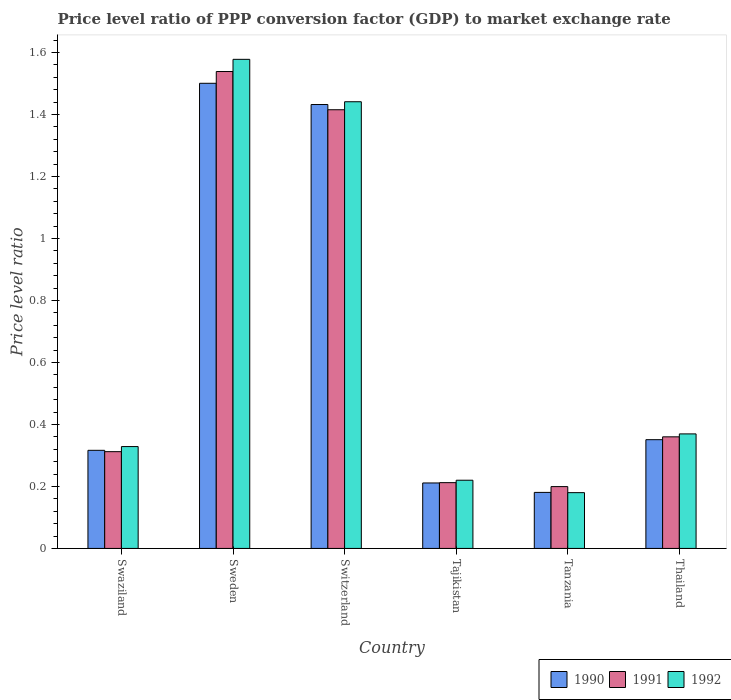How many different coloured bars are there?
Offer a very short reply. 3. Are the number of bars on each tick of the X-axis equal?
Make the answer very short. Yes. What is the label of the 6th group of bars from the left?
Keep it short and to the point. Thailand. What is the price level ratio in 1992 in Thailand?
Offer a terse response. 0.37. Across all countries, what is the maximum price level ratio in 1991?
Your answer should be very brief. 1.54. Across all countries, what is the minimum price level ratio in 1992?
Offer a very short reply. 0.18. In which country was the price level ratio in 1990 minimum?
Provide a succinct answer. Tanzania. What is the total price level ratio in 1992 in the graph?
Give a very brief answer. 4.12. What is the difference between the price level ratio in 1990 in Swaziland and that in Thailand?
Offer a terse response. -0.03. What is the difference between the price level ratio in 1992 in Thailand and the price level ratio in 1990 in Tanzania?
Provide a succinct answer. 0.19. What is the average price level ratio in 1990 per country?
Ensure brevity in your answer.  0.67. What is the difference between the price level ratio of/in 1991 and price level ratio of/in 1990 in Tajikistan?
Your response must be concise. 0. In how many countries, is the price level ratio in 1991 greater than 0.7200000000000001?
Your answer should be compact. 2. What is the ratio of the price level ratio in 1990 in Tajikistan to that in Thailand?
Your answer should be compact. 0.6. Is the difference between the price level ratio in 1991 in Swaziland and Sweden greater than the difference between the price level ratio in 1990 in Swaziland and Sweden?
Ensure brevity in your answer.  No. What is the difference between the highest and the second highest price level ratio in 1991?
Give a very brief answer. -1.18. What is the difference between the highest and the lowest price level ratio in 1990?
Make the answer very short. 1.32. In how many countries, is the price level ratio in 1992 greater than the average price level ratio in 1992 taken over all countries?
Keep it short and to the point. 2. What does the 2nd bar from the left in Tajikistan represents?
Ensure brevity in your answer.  1991. Is it the case that in every country, the sum of the price level ratio in 1992 and price level ratio in 1990 is greater than the price level ratio in 1991?
Give a very brief answer. Yes. How many bars are there?
Your answer should be compact. 18. How many countries are there in the graph?
Provide a short and direct response. 6. Does the graph contain any zero values?
Your answer should be compact. No. Where does the legend appear in the graph?
Your answer should be compact. Bottom right. How are the legend labels stacked?
Your answer should be very brief. Horizontal. What is the title of the graph?
Ensure brevity in your answer.  Price level ratio of PPP conversion factor (GDP) to market exchange rate. What is the label or title of the X-axis?
Give a very brief answer. Country. What is the label or title of the Y-axis?
Provide a short and direct response. Price level ratio. What is the Price level ratio in 1990 in Swaziland?
Offer a terse response. 0.32. What is the Price level ratio of 1991 in Swaziland?
Offer a terse response. 0.31. What is the Price level ratio in 1992 in Swaziland?
Provide a short and direct response. 0.33. What is the Price level ratio in 1990 in Sweden?
Offer a terse response. 1.5. What is the Price level ratio in 1991 in Sweden?
Keep it short and to the point. 1.54. What is the Price level ratio in 1992 in Sweden?
Provide a short and direct response. 1.58. What is the Price level ratio of 1990 in Switzerland?
Offer a terse response. 1.43. What is the Price level ratio of 1991 in Switzerland?
Offer a terse response. 1.42. What is the Price level ratio of 1992 in Switzerland?
Ensure brevity in your answer.  1.44. What is the Price level ratio in 1990 in Tajikistan?
Your response must be concise. 0.21. What is the Price level ratio in 1991 in Tajikistan?
Keep it short and to the point. 0.21. What is the Price level ratio of 1992 in Tajikistan?
Ensure brevity in your answer.  0.22. What is the Price level ratio in 1990 in Tanzania?
Offer a terse response. 0.18. What is the Price level ratio in 1991 in Tanzania?
Keep it short and to the point. 0.2. What is the Price level ratio in 1992 in Tanzania?
Ensure brevity in your answer.  0.18. What is the Price level ratio of 1990 in Thailand?
Your response must be concise. 0.35. What is the Price level ratio in 1991 in Thailand?
Ensure brevity in your answer.  0.36. What is the Price level ratio in 1992 in Thailand?
Keep it short and to the point. 0.37. Across all countries, what is the maximum Price level ratio in 1990?
Give a very brief answer. 1.5. Across all countries, what is the maximum Price level ratio in 1991?
Provide a succinct answer. 1.54. Across all countries, what is the maximum Price level ratio of 1992?
Provide a short and direct response. 1.58. Across all countries, what is the minimum Price level ratio in 1990?
Ensure brevity in your answer.  0.18. Across all countries, what is the minimum Price level ratio of 1991?
Offer a terse response. 0.2. Across all countries, what is the minimum Price level ratio in 1992?
Provide a short and direct response. 0.18. What is the total Price level ratio of 1990 in the graph?
Make the answer very short. 3.99. What is the total Price level ratio in 1991 in the graph?
Your answer should be compact. 4.04. What is the total Price level ratio of 1992 in the graph?
Keep it short and to the point. 4.12. What is the difference between the Price level ratio of 1990 in Swaziland and that in Sweden?
Keep it short and to the point. -1.18. What is the difference between the Price level ratio of 1991 in Swaziland and that in Sweden?
Give a very brief answer. -1.23. What is the difference between the Price level ratio in 1992 in Swaziland and that in Sweden?
Give a very brief answer. -1.25. What is the difference between the Price level ratio of 1990 in Swaziland and that in Switzerland?
Provide a short and direct response. -1.12. What is the difference between the Price level ratio in 1991 in Swaziland and that in Switzerland?
Keep it short and to the point. -1.1. What is the difference between the Price level ratio of 1992 in Swaziland and that in Switzerland?
Provide a short and direct response. -1.11. What is the difference between the Price level ratio of 1990 in Swaziland and that in Tajikistan?
Make the answer very short. 0.11. What is the difference between the Price level ratio in 1991 in Swaziland and that in Tajikistan?
Your answer should be compact. 0.1. What is the difference between the Price level ratio of 1992 in Swaziland and that in Tajikistan?
Ensure brevity in your answer.  0.11. What is the difference between the Price level ratio in 1990 in Swaziland and that in Tanzania?
Offer a very short reply. 0.14. What is the difference between the Price level ratio of 1991 in Swaziland and that in Tanzania?
Provide a short and direct response. 0.11. What is the difference between the Price level ratio of 1992 in Swaziland and that in Tanzania?
Make the answer very short. 0.15. What is the difference between the Price level ratio of 1990 in Swaziland and that in Thailand?
Offer a very short reply. -0.03. What is the difference between the Price level ratio in 1991 in Swaziland and that in Thailand?
Your answer should be very brief. -0.05. What is the difference between the Price level ratio in 1992 in Swaziland and that in Thailand?
Offer a very short reply. -0.04. What is the difference between the Price level ratio in 1990 in Sweden and that in Switzerland?
Your answer should be compact. 0.07. What is the difference between the Price level ratio of 1991 in Sweden and that in Switzerland?
Give a very brief answer. 0.12. What is the difference between the Price level ratio of 1992 in Sweden and that in Switzerland?
Offer a terse response. 0.14. What is the difference between the Price level ratio in 1990 in Sweden and that in Tajikistan?
Your response must be concise. 1.29. What is the difference between the Price level ratio of 1991 in Sweden and that in Tajikistan?
Provide a succinct answer. 1.33. What is the difference between the Price level ratio in 1992 in Sweden and that in Tajikistan?
Your answer should be compact. 1.36. What is the difference between the Price level ratio in 1990 in Sweden and that in Tanzania?
Make the answer very short. 1.32. What is the difference between the Price level ratio of 1991 in Sweden and that in Tanzania?
Make the answer very short. 1.34. What is the difference between the Price level ratio in 1992 in Sweden and that in Tanzania?
Offer a terse response. 1.4. What is the difference between the Price level ratio in 1990 in Sweden and that in Thailand?
Your response must be concise. 1.15. What is the difference between the Price level ratio in 1991 in Sweden and that in Thailand?
Offer a very short reply. 1.18. What is the difference between the Price level ratio in 1992 in Sweden and that in Thailand?
Your response must be concise. 1.21. What is the difference between the Price level ratio in 1990 in Switzerland and that in Tajikistan?
Offer a very short reply. 1.22. What is the difference between the Price level ratio of 1991 in Switzerland and that in Tajikistan?
Offer a very short reply. 1.2. What is the difference between the Price level ratio in 1992 in Switzerland and that in Tajikistan?
Give a very brief answer. 1.22. What is the difference between the Price level ratio of 1990 in Switzerland and that in Tanzania?
Make the answer very short. 1.25. What is the difference between the Price level ratio in 1991 in Switzerland and that in Tanzania?
Your answer should be very brief. 1.22. What is the difference between the Price level ratio of 1992 in Switzerland and that in Tanzania?
Provide a succinct answer. 1.26. What is the difference between the Price level ratio in 1990 in Switzerland and that in Thailand?
Your response must be concise. 1.08. What is the difference between the Price level ratio in 1991 in Switzerland and that in Thailand?
Ensure brevity in your answer.  1.06. What is the difference between the Price level ratio in 1992 in Switzerland and that in Thailand?
Offer a very short reply. 1.07. What is the difference between the Price level ratio in 1990 in Tajikistan and that in Tanzania?
Ensure brevity in your answer.  0.03. What is the difference between the Price level ratio of 1991 in Tajikistan and that in Tanzania?
Your answer should be very brief. 0.01. What is the difference between the Price level ratio in 1992 in Tajikistan and that in Tanzania?
Your response must be concise. 0.04. What is the difference between the Price level ratio in 1990 in Tajikistan and that in Thailand?
Ensure brevity in your answer.  -0.14. What is the difference between the Price level ratio in 1991 in Tajikistan and that in Thailand?
Ensure brevity in your answer.  -0.15. What is the difference between the Price level ratio in 1992 in Tajikistan and that in Thailand?
Ensure brevity in your answer.  -0.15. What is the difference between the Price level ratio of 1990 in Tanzania and that in Thailand?
Keep it short and to the point. -0.17. What is the difference between the Price level ratio of 1991 in Tanzania and that in Thailand?
Ensure brevity in your answer.  -0.16. What is the difference between the Price level ratio in 1992 in Tanzania and that in Thailand?
Make the answer very short. -0.19. What is the difference between the Price level ratio in 1990 in Swaziland and the Price level ratio in 1991 in Sweden?
Make the answer very short. -1.22. What is the difference between the Price level ratio of 1990 in Swaziland and the Price level ratio of 1992 in Sweden?
Offer a very short reply. -1.26. What is the difference between the Price level ratio in 1991 in Swaziland and the Price level ratio in 1992 in Sweden?
Ensure brevity in your answer.  -1.27. What is the difference between the Price level ratio in 1990 in Swaziland and the Price level ratio in 1991 in Switzerland?
Provide a short and direct response. -1.1. What is the difference between the Price level ratio in 1990 in Swaziland and the Price level ratio in 1992 in Switzerland?
Provide a short and direct response. -1.12. What is the difference between the Price level ratio in 1991 in Swaziland and the Price level ratio in 1992 in Switzerland?
Make the answer very short. -1.13. What is the difference between the Price level ratio of 1990 in Swaziland and the Price level ratio of 1991 in Tajikistan?
Offer a terse response. 0.1. What is the difference between the Price level ratio of 1990 in Swaziland and the Price level ratio of 1992 in Tajikistan?
Your response must be concise. 0.1. What is the difference between the Price level ratio of 1991 in Swaziland and the Price level ratio of 1992 in Tajikistan?
Provide a short and direct response. 0.09. What is the difference between the Price level ratio of 1990 in Swaziland and the Price level ratio of 1991 in Tanzania?
Keep it short and to the point. 0.12. What is the difference between the Price level ratio in 1990 in Swaziland and the Price level ratio in 1992 in Tanzania?
Make the answer very short. 0.14. What is the difference between the Price level ratio in 1991 in Swaziland and the Price level ratio in 1992 in Tanzania?
Offer a very short reply. 0.13. What is the difference between the Price level ratio of 1990 in Swaziland and the Price level ratio of 1991 in Thailand?
Provide a succinct answer. -0.04. What is the difference between the Price level ratio of 1990 in Swaziland and the Price level ratio of 1992 in Thailand?
Ensure brevity in your answer.  -0.05. What is the difference between the Price level ratio of 1991 in Swaziland and the Price level ratio of 1992 in Thailand?
Your response must be concise. -0.06. What is the difference between the Price level ratio in 1990 in Sweden and the Price level ratio in 1991 in Switzerland?
Keep it short and to the point. 0.09. What is the difference between the Price level ratio of 1990 in Sweden and the Price level ratio of 1992 in Switzerland?
Provide a short and direct response. 0.06. What is the difference between the Price level ratio in 1991 in Sweden and the Price level ratio in 1992 in Switzerland?
Provide a succinct answer. 0.1. What is the difference between the Price level ratio of 1990 in Sweden and the Price level ratio of 1991 in Tajikistan?
Your response must be concise. 1.29. What is the difference between the Price level ratio in 1990 in Sweden and the Price level ratio in 1992 in Tajikistan?
Ensure brevity in your answer.  1.28. What is the difference between the Price level ratio in 1991 in Sweden and the Price level ratio in 1992 in Tajikistan?
Give a very brief answer. 1.32. What is the difference between the Price level ratio in 1990 in Sweden and the Price level ratio in 1991 in Tanzania?
Your answer should be compact. 1.3. What is the difference between the Price level ratio in 1990 in Sweden and the Price level ratio in 1992 in Tanzania?
Provide a succinct answer. 1.32. What is the difference between the Price level ratio of 1991 in Sweden and the Price level ratio of 1992 in Tanzania?
Keep it short and to the point. 1.36. What is the difference between the Price level ratio of 1990 in Sweden and the Price level ratio of 1991 in Thailand?
Provide a short and direct response. 1.14. What is the difference between the Price level ratio of 1990 in Sweden and the Price level ratio of 1992 in Thailand?
Ensure brevity in your answer.  1.13. What is the difference between the Price level ratio of 1991 in Sweden and the Price level ratio of 1992 in Thailand?
Offer a very short reply. 1.17. What is the difference between the Price level ratio of 1990 in Switzerland and the Price level ratio of 1991 in Tajikistan?
Offer a very short reply. 1.22. What is the difference between the Price level ratio of 1990 in Switzerland and the Price level ratio of 1992 in Tajikistan?
Make the answer very short. 1.21. What is the difference between the Price level ratio of 1991 in Switzerland and the Price level ratio of 1992 in Tajikistan?
Your answer should be compact. 1.2. What is the difference between the Price level ratio in 1990 in Switzerland and the Price level ratio in 1991 in Tanzania?
Give a very brief answer. 1.23. What is the difference between the Price level ratio in 1990 in Switzerland and the Price level ratio in 1992 in Tanzania?
Keep it short and to the point. 1.25. What is the difference between the Price level ratio of 1991 in Switzerland and the Price level ratio of 1992 in Tanzania?
Provide a short and direct response. 1.24. What is the difference between the Price level ratio of 1990 in Switzerland and the Price level ratio of 1991 in Thailand?
Provide a succinct answer. 1.07. What is the difference between the Price level ratio of 1990 in Switzerland and the Price level ratio of 1992 in Thailand?
Give a very brief answer. 1.06. What is the difference between the Price level ratio of 1991 in Switzerland and the Price level ratio of 1992 in Thailand?
Provide a short and direct response. 1.05. What is the difference between the Price level ratio of 1990 in Tajikistan and the Price level ratio of 1991 in Tanzania?
Your answer should be very brief. 0.01. What is the difference between the Price level ratio of 1990 in Tajikistan and the Price level ratio of 1992 in Tanzania?
Your answer should be very brief. 0.03. What is the difference between the Price level ratio in 1991 in Tajikistan and the Price level ratio in 1992 in Tanzania?
Your answer should be compact. 0.03. What is the difference between the Price level ratio of 1990 in Tajikistan and the Price level ratio of 1991 in Thailand?
Your response must be concise. -0.15. What is the difference between the Price level ratio in 1990 in Tajikistan and the Price level ratio in 1992 in Thailand?
Provide a succinct answer. -0.16. What is the difference between the Price level ratio in 1991 in Tajikistan and the Price level ratio in 1992 in Thailand?
Give a very brief answer. -0.16. What is the difference between the Price level ratio in 1990 in Tanzania and the Price level ratio in 1991 in Thailand?
Your response must be concise. -0.18. What is the difference between the Price level ratio of 1990 in Tanzania and the Price level ratio of 1992 in Thailand?
Ensure brevity in your answer.  -0.19. What is the difference between the Price level ratio in 1991 in Tanzania and the Price level ratio in 1992 in Thailand?
Make the answer very short. -0.17. What is the average Price level ratio in 1990 per country?
Keep it short and to the point. 0.67. What is the average Price level ratio in 1991 per country?
Your answer should be very brief. 0.67. What is the average Price level ratio in 1992 per country?
Keep it short and to the point. 0.69. What is the difference between the Price level ratio in 1990 and Price level ratio in 1991 in Swaziland?
Offer a very short reply. 0. What is the difference between the Price level ratio in 1990 and Price level ratio in 1992 in Swaziland?
Your answer should be compact. -0.01. What is the difference between the Price level ratio of 1991 and Price level ratio of 1992 in Swaziland?
Your answer should be compact. -0.02. What is the difference between the Price level ratio in 1990 and Price level ratio in 1991 in Sweden?
Give a very brief answer. -0.04. What is the difference between the Price level ratio in 1990 and Price level ratio in 1992 in Sweden?
Give a very brief answer. -0.08. What is the difference between the Price level ratio in 1991 and Price level ratio in 1992 in Sweden?
Your answer should be compact. -0.04. What is the difference between the Price level ratio in 1990 and Price level ratio in 1991 in Switzerland?
Ensure brevity in your answer.  0.02. What is the difference between the Price level ratio of 1990 and Price level ratio of 1992 in Switzerland?
Provide a short and direct response. -0.01. What is the difference between the Price level ratio of 1991 and Price level ratio of 1992 in Switzerland?
Ensure brevity in your answer.  -0.03. What is the difference between the Price level ratio of 1990 and Price level ratio of 1991 in Tajikistan?
Ensure brevity in your answer.  -0. What is the difference between the Price level ratio in 1990 and Price level ratio in 1992 in Tajikistan?
Provide a succinct answer. -0.01. What is the difference between the Price level ratio of 1991 and Price level ratio of 1992 in Tajikistan?
Give a very brief answer. -0.01. What is the difference between the Price level ratio of 1990 and Price level ratio of 1991 in Tanzania?
Keep it short and to the point. -0.02. What is the difference between the Price level ratio of 1990 and Price level ratio of 1992 in Tanzania?
Keep it short and to the point. 0. What is the difference between the Price level ratio in 1991 and Price level ratio in 1992 in Tanzania?
Ensure brevity in your answer.  0.02. What is the difference between the Price level ratio in 1990 and Price level ratio in 1991 in Thailand?
Your response must be concise. -0.01. What is the difference between the Price level ratio of 1990 and Price level ratio of 1992 in Thailand?
Offer a terse response. -0.02. What is the difference between the Price level ratio of 1991 and Price level ratio of 1992 in Thailand?
Offer a terse response. -0.01. What is the ratio of the Price level ratio of 1990 in Swaziland to that in Sweden?
Keep it short and to the point. 0.21. What is the ratio of the Price level ratio in 1991 in Swaziland to that in Sweden?
Offer a terse response. 0.2. What is the ratio of the Price level ratio in 1992 in Swaziland to that in Sweden?
Keep it short and to the point. 0.21. What is the ratio of the Price level ratio of 1990 in Swaziland to that in Switzerland?
Your response must be concise. 0.22. What is the ratio of the Price level ratio in 1991 in Swaziland to that in Switzerland?
Offer a terse response. 0.22. What is the ratio of the Price level ratio of 1992 in Swaziland to that in Switzerland?
Ensure brevity in your answer.  0.23. What is the ratio of the Price level ratio of 1990 in Swaziland to that in Tajikistan?
Provide a succinct answer. 1.5. What is the ratio of the Price level ratio of 1991 in Swaziland to that in Tajikistan?
Make the answer very short. 1.47. What is the ratio of the Price level ratio in 1992 in Swaziland to that in Tajikistan?
Your answer should be very brief. 1.49. What is the ratio of the Price level ratio of 1990 in Swaziland to that in Tanzania?
Your answer should be very brief. 1.75. What is the ratio of the Price level ratio of 1991 in Swaziland to that in Tanzania?
Give a very brief answer. 1.57. What is the ratio of the Price level ratio in 1992 in Swaziland to that in Tanzania?
Ensure brevity in your answer.  1.83. What is the ratio of the Price level ratio in 1990 in Swaziland to that in Thailand?
Your response must be concise. 0.9. What is the ratio of the Price level ratio in 1991 in Swaziland to that in Thailand?
Your response must be concise. 0.87. What is the ratio of the Price level ratio of 1992 in Swaziland to that in Thailand?
Keep it short and to the point. 0.89. What is the ratio of the Price level ratio of 1990 in Sweden to that in Switzerland?
Offer a terse response. 1.05. What is the ratio of the Price level ratio in 1991 in Sweden to that in Switzerland?
Provide a succinct answer. 1.09. What is the ratio of the Price level ratio in 1992 in Sweden to that in Switzerland?
Make the answer very short. 1.09. What is the ratio of the Price level ratio in 1990 in Sweden to that in Tajikistan?
Give a very brief answer. 7.1. What is the ratio of the Price level ratio of 1991 in Sweden to that in Tajikistan?
Keep it short and to the point. 7.25. What is the ratio of the Price level ratio of 1992 in Sweden to that in Tajikistan?
Your answer should be compact. 7.17. What is the ratio of the Price level ratio in 1990 in Sweden to that in Tanzania?
Provide a short and direct response. 8.3. What is the ratio of the Price level ratio of 1991 in Sweden to that in Tanzania?
Your answer should be compact. 7.71. What is the ratio of the Price level ratio of 1992 in Sweden to that in Tanzania?
Your response must be concise. 8.77. What is the ratio of the Price level ratio of 1990 in Sweden to that in Thailand?
Your answer should be very brief. 4.28. What is the ratio of the Price level ratio in 1991 in Sweden to that in Thailand?
Make the answer very short. 4.27. What is the ratio of the Price level ratio of 1992 in Sweden to that in Thailand?
Offer a very short reply. 4.27. What is the ratio of the Price level ratio of 1990 in Switzerland to that in Tajikistan?
Give a very brief answer. 6.78. What is the ratio of the Price level ratio of 1991 in Switzerland to that in Tajikistan?
Your answer should be compact. 6.67. What is the ratio of the Price level ratio in 1992 in Switzerland to that in Tajikistan?
Make the answer very short. 6.55. What is the ratio of the Price level ratio in 1990 in Switzerland to that in Tanzania?
Provide a short and direct response. 7.92. What is the ratio of the Price level ratio of 1991 in Switzerland to that in Tanzania?
Offer a terse response. 7.1. What is the ratio of the Price level ratio of 1992 in Switzerland to that in Tanzania?
Ensure brevity in your answer.  8.01. What is the ratio of the Price level ratio in 1990 in Switzerland to that in Thailand?
Offer a very short reply. 4.08. What is the ratio of the Price level ratio of 1991 in Switzerland to that in Thailand?
Give a very brief answer. 3.93. What is the ratio of the Price level ratio in 1992 in Switzerland to that in Thailand?
Keep it short and to the point. 3.9. What is the ratio of the Price level ratio of 1990 in Tajikistan to that in Tanzania?
Make the answer very short. 1.17. What is the ratio of the Price level ratio in 1991 in Tajikistan to that in Tanzania?
Your answer should be very brief. 1.06. What is the ratio of the Price level ratio of 1992 in Tajikistan to that in Tanzania?
Offer a terse response. 1.22. What is the ratio of the Price level ratio in 1990 in Tajikistan to that in Thailand?
Offer a terse response. 0.6. What is the ratio of the Price level ratio of 1991 in Tajikistan to that in Thailand?
Keep it short and to the point. 0.59. What is the ratio of the Price level ratio in 1992 in Tajikistan to that in Thailand?
Provide a succinct answer. 0.6. What is the ratio of the Price level ratio of 1990 in Tanzania to that in Thailand?
Give a very brief answer. 0.52. What is the ratio of the Price level ratio in 1991 in Tanzania to that in Thailand?
Offer a very short reply. 0.55. What is the ratio of the Price level ratio of 1992 in Tanzania to that in Thailand?
Offer a very short reply. 0.49. What is the difference between the highest and the second highest Price level ratio in 1990?
Give a very brief answer. 0.07. What is the difference between the highest and the second highest Price level ratio in 1991?
Give a very brief answer. 0.12. What is the difference between the highest and the second highest Price level ratio of 1992?
Your answer should be very brief. 0.14. What is the difference between the highest and the lowest Price level ratio of 1990?
Ensure brevity in your answer.  1.32. What is the difference between the highest and the lowest Price level ratio of 1991?
Keep it short and to the point. 1.34. What is the difference between the highest and the lowest Price level ratio in 1992?
Offer a terse response. 1.4. 